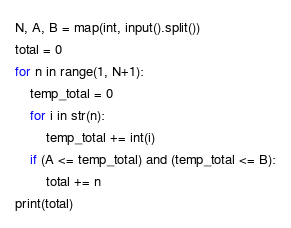Convert code to text. <code><loc_0><loc_0><loc_500><loc_500><_Python_>N, A, B = map(int, input().split())
total = 0
for n in range(1, N+1):
    temp_total = 0
    for i in str(n):
        temp_total += int(i)
    if (A <= temp_total) and (temp_total <= B):
        total += n
print(total)</code> 